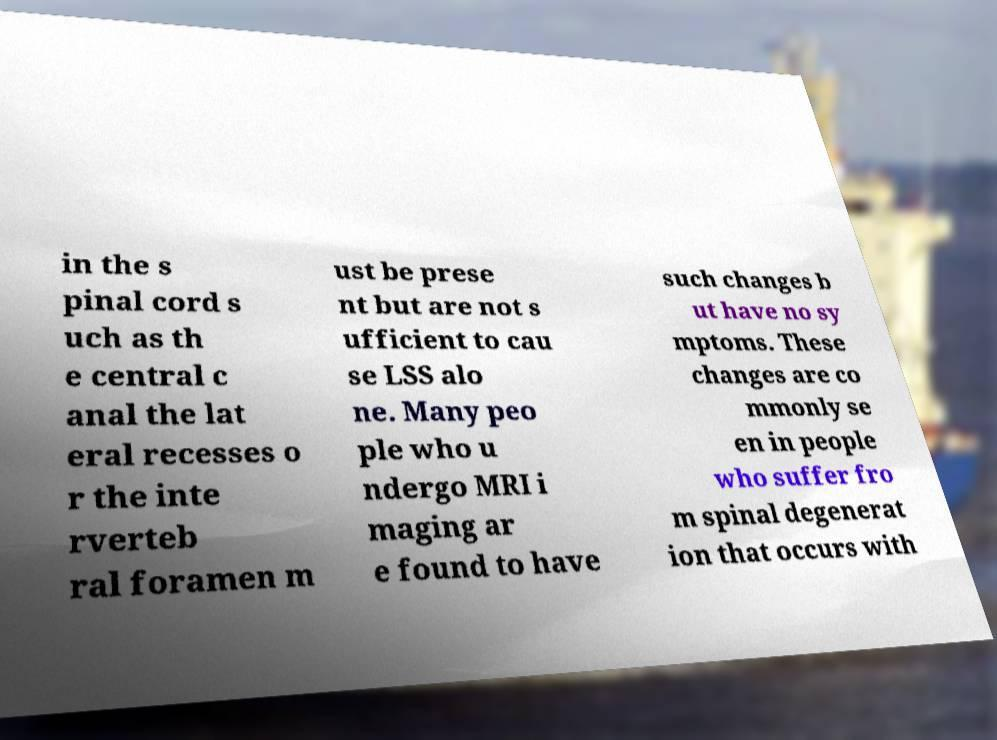Could you extract and type out the text from this image? in the s pinal cord s uch as th e central c anal the lat eral recesses o r the inte rverteb ral foramen m ust be prese nt but are not s ufficient to cau se LSS alo ne. Many peo ple who u ndergo MRI i maging ar e found to have such changes b ut have no sy mptoms. These changes are co mmonly se en in people who suffer fro m spinal degenerat ion that occurs with 